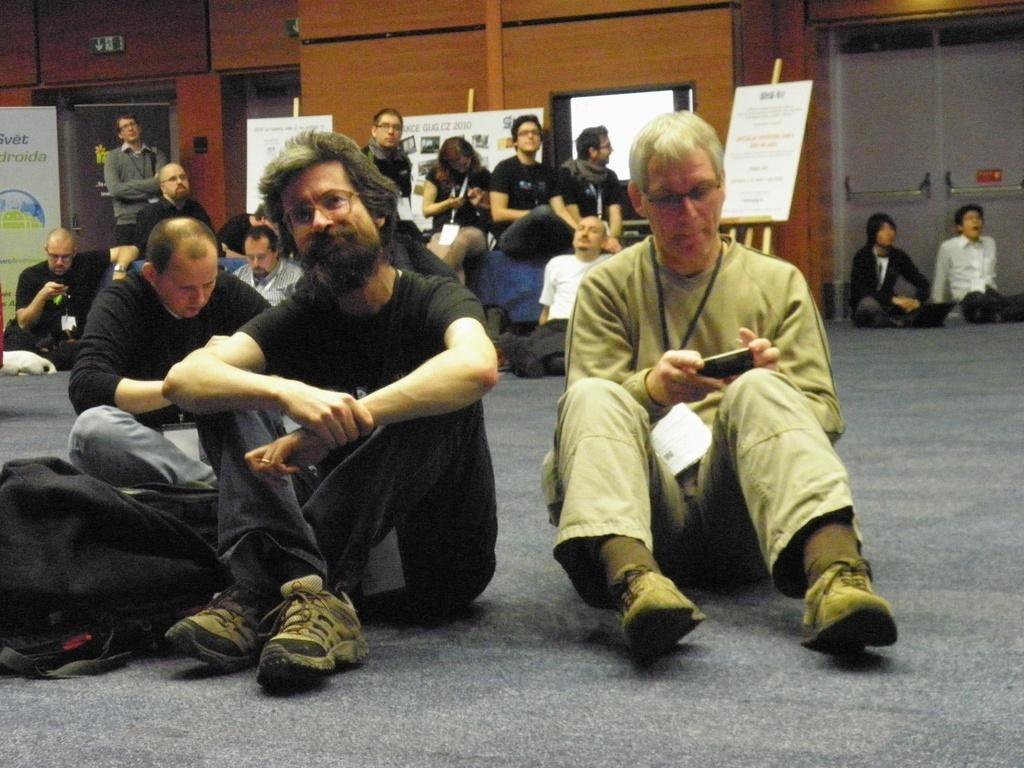What are the people in the image doing? The people in the image are sitting on the floor. What can be seen in the image besides the people? There is a wooden stand, boards, a hoarding on the left side, and a wooden wall in the image. How many chickens are visible in the image? There are no chickens present in the image. What type of muscle is being exercised by the people sitting on the floor? The image does not provide information about the people's muscles or any exercise they might be doing. 